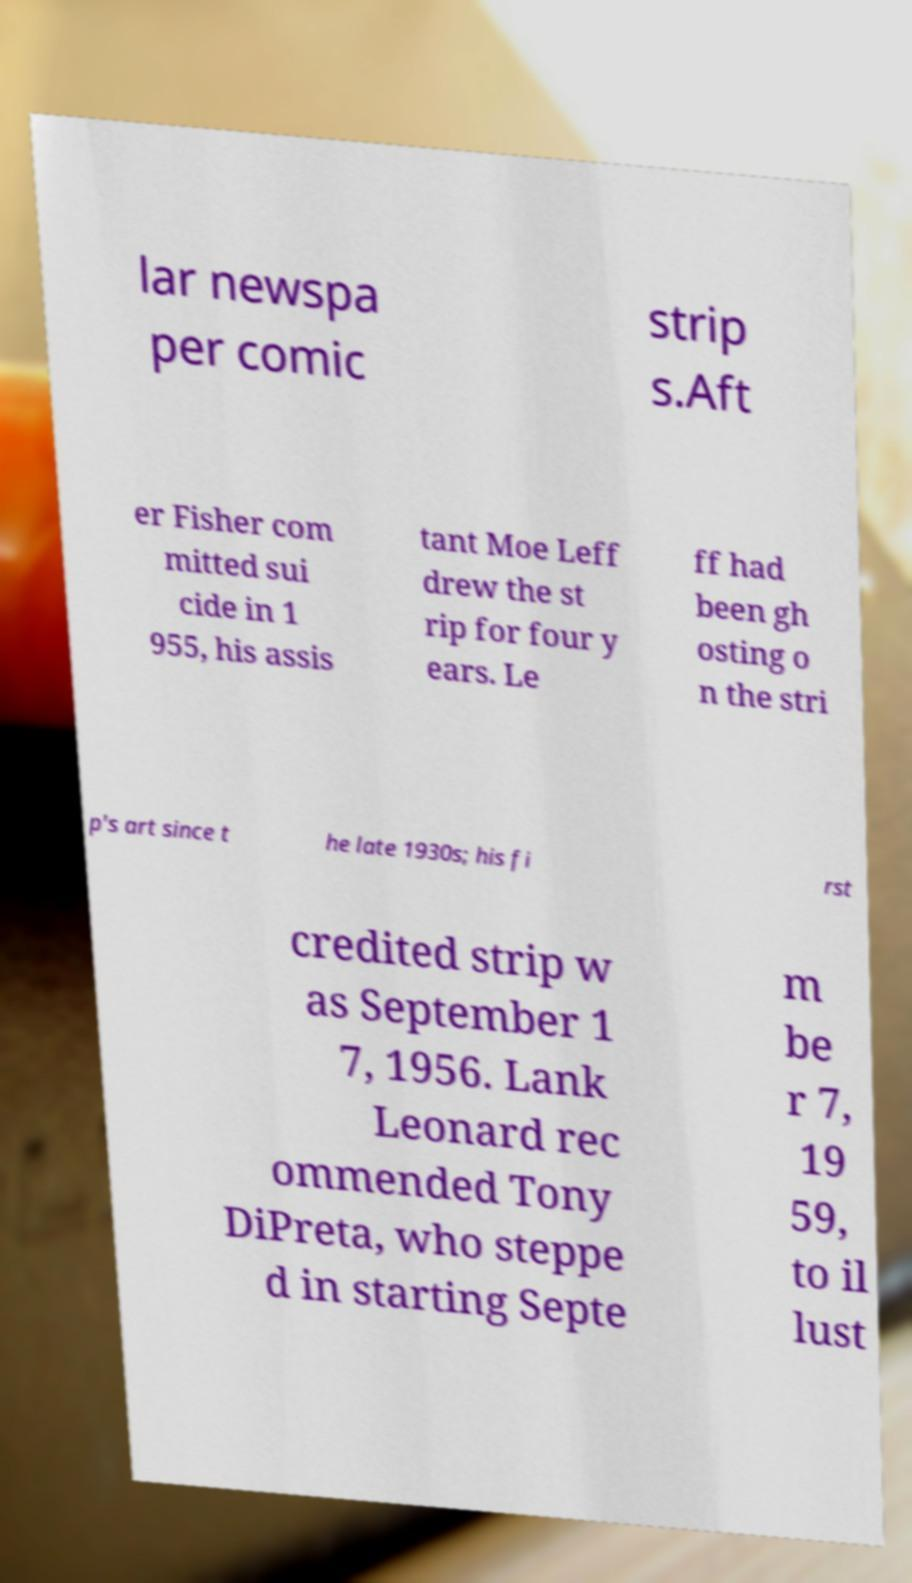Could you assist in decoding the text presented in this image and type it out clearly? lar newspa per comic strip s.Aft er Fisher com mitted sui cide in 1 955, his assis tant Moe Leff drew the st rip for four y ears. Le ff had been gh osting o n the stri p's art since t he late 1930s; his fi rst credited strip w as September 1 7, 1956. Lank Leonard rec ommended Tony DiPreta, who steppe d in starting Septe m be r 7, 19 59, to il lust 